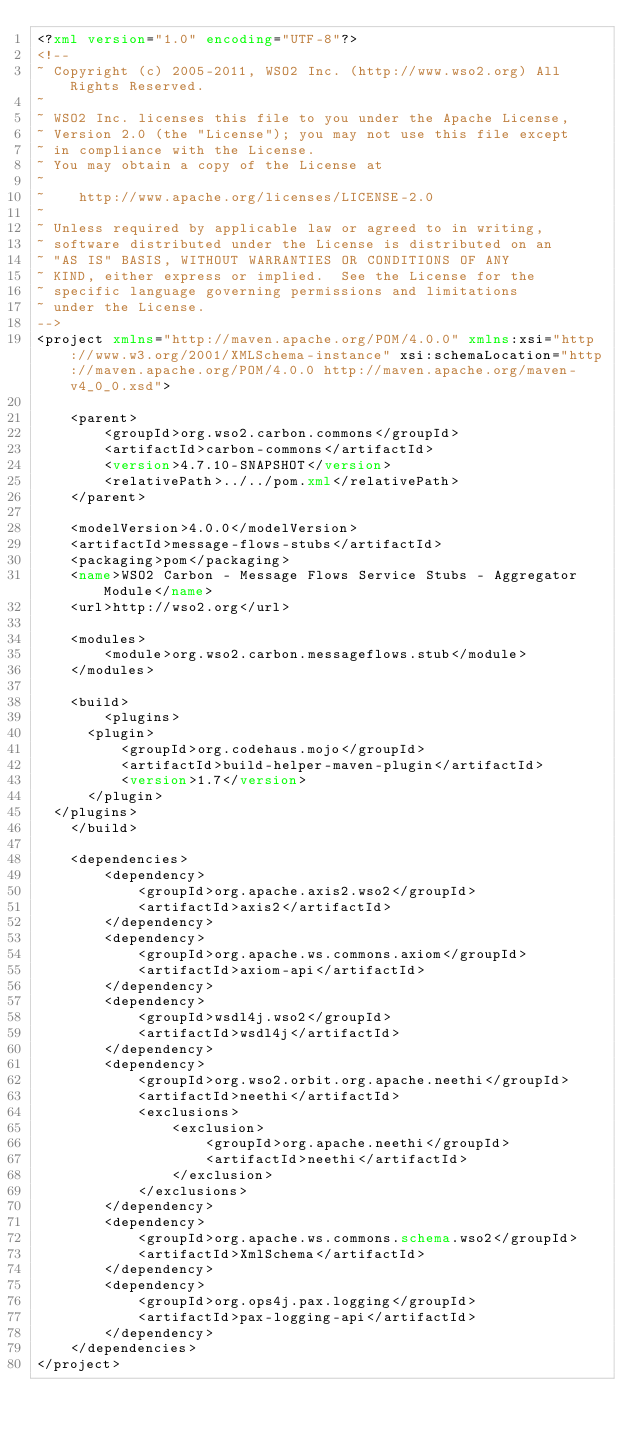<code> <loc_0><loc_0><loc_500><loc_500><_XML_><?xml version="1.0" encoding="UTF-8"?>
<!--
~ Copyright (c) 2005-2011, WSO2 Inc. (http://www.wso2.org) All Rights Reserved.
~
~ WSO2 Inc. licenses this file to you under the Apache License,
~ Version 2.0 (the "License"); you may not use this file except
~ in compliance with the License.
~ You may obtain a copy of the License at
~
~    http://www.apache.org/licenses/LICENSE-2.0
~
~ Unless required by applicable law or agreed to in writing,
~ software distributed under the License is distributed on an
~ "AS IS" BASIS, WITHOUT WARRANTIES OR CONDITIONS OF ANY
~ KIND, either express or implied.  See the License for the
~ specific language governing permissions and limitations
~ under the License.
-->
<project xmlns="http://maven.apache.org/POM/4.0.0" xmlns:xsi="http://www.w3.org/2001/XMLSchema-instance" xsi:schemaLocation="http://maven.apache.org/POM/4.0.0 http://maven.apache.org/maven-v4_0_0.xsd">
    
    <parent>
        <groupId>org.wso2.carbon.commons</groupId>
        <artifactId>carbon-commons</artifactId>
        <version>4.7.10-SNAPSHOT</version>
        <relativePath>../../pom.xml</relativePath>
    </parent>
    
    <modelVersion>4.0.0</modelVersion>
    <artifactId>message-flows-stubs</artifactId>
    <packaging>pom</packaging>
    <name>WSO2 Carbon - Message Flows Service Stubs - Aggregator Module</name>
    <url>http://wso2.org</url>
    
    <modules>
        <module>org.wso2.carbon.messageflows.stub</module>
    </modules>
    
    <build>
        <plugins>
	    <plugin>
	        <groupId>org.codehaus.mojo</groupId>
	        <artifactId>build-helper-maven-plugin</artifactId>
	        <version>1.7</version>
	    </plugin>
	</plugins>
    </build>

    <dependencies>
        <dependency>
            <groupId>org.apache.axis2.wso2</groupId>
            <artifactId>axis2</artifactId>
        </dependency>
        <dependency>
            <groupId>org.apache.ws.commons.axiom</groupId>
            <artifactId>axiom-api</artifactId>
        </dependency>
        <dependency>
            <groupId>wsdl4j.wso2</groupId>
            <artifactId>wsdl4j</artifactId>
        </dependency>
        <dependency>
            <groupId>org.wso2.orbit.org.apache.neethi</groupId>
            <artifactId>neethi</artifactId>
            <exclusions>
                <exclusion>
                    <groupId>org.apache.neethi</groupId>
                    <artifactId>neethi</artifactId>
                </exclusion>
            </exclusions>
        </dependency>
        <dependency>
            <groupId>org.apache.ws.commons.schema.wso2</groupId>
            <artifactId>XmlSchema</artifactId>
        </dependency>
        <dependency>
            <groupId>org.ops4j.pax.logging</groupId>
            <artifactId>pax-logging-api</artifactId>
        </dependency>
    </dependencies>
</project>
</code> 